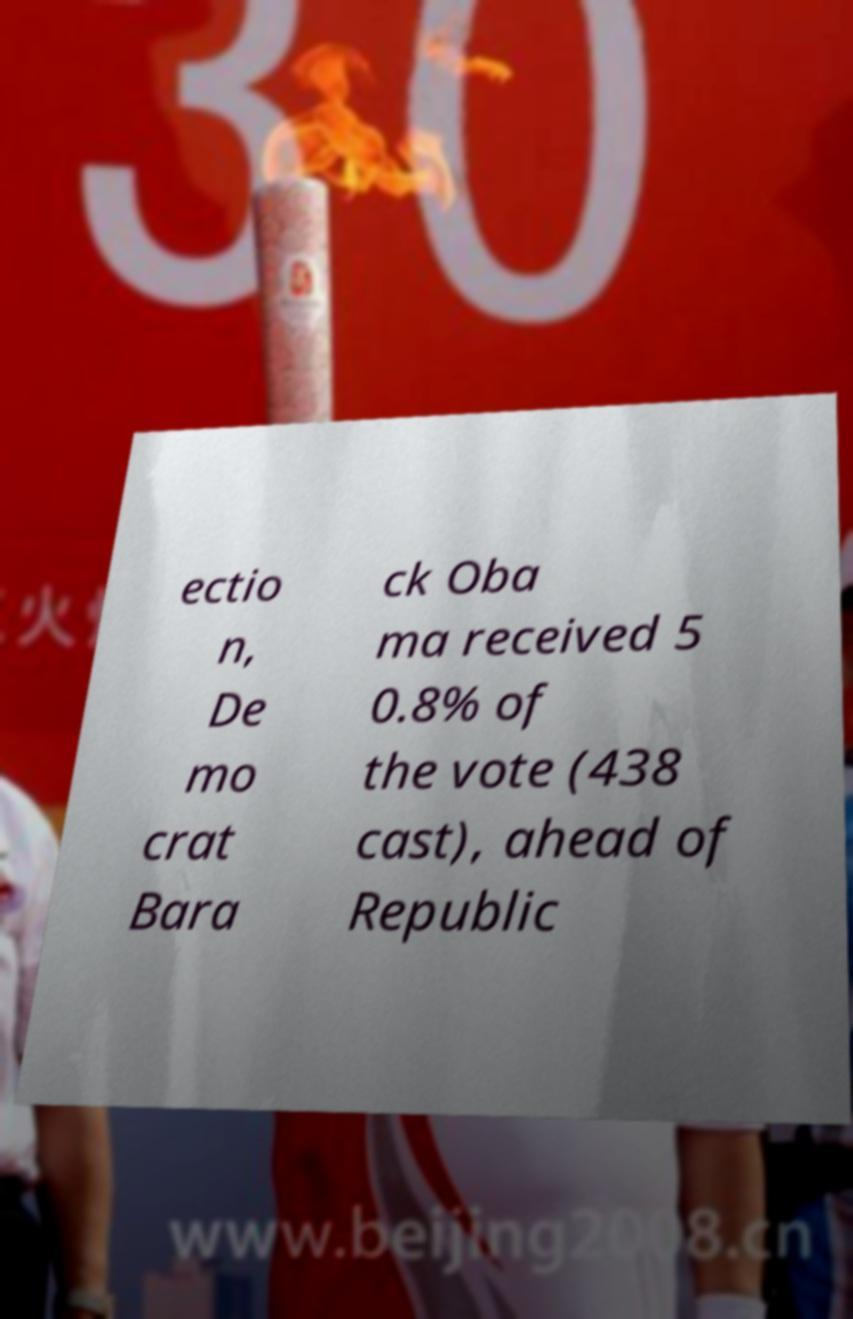There's text embedded in this image that I need extracted. Can you transcribe it verbatim? ectio n, De mo crat Bara ck Oba ma received 5 0.8% of the vote (438 cast), ahead of Republic 